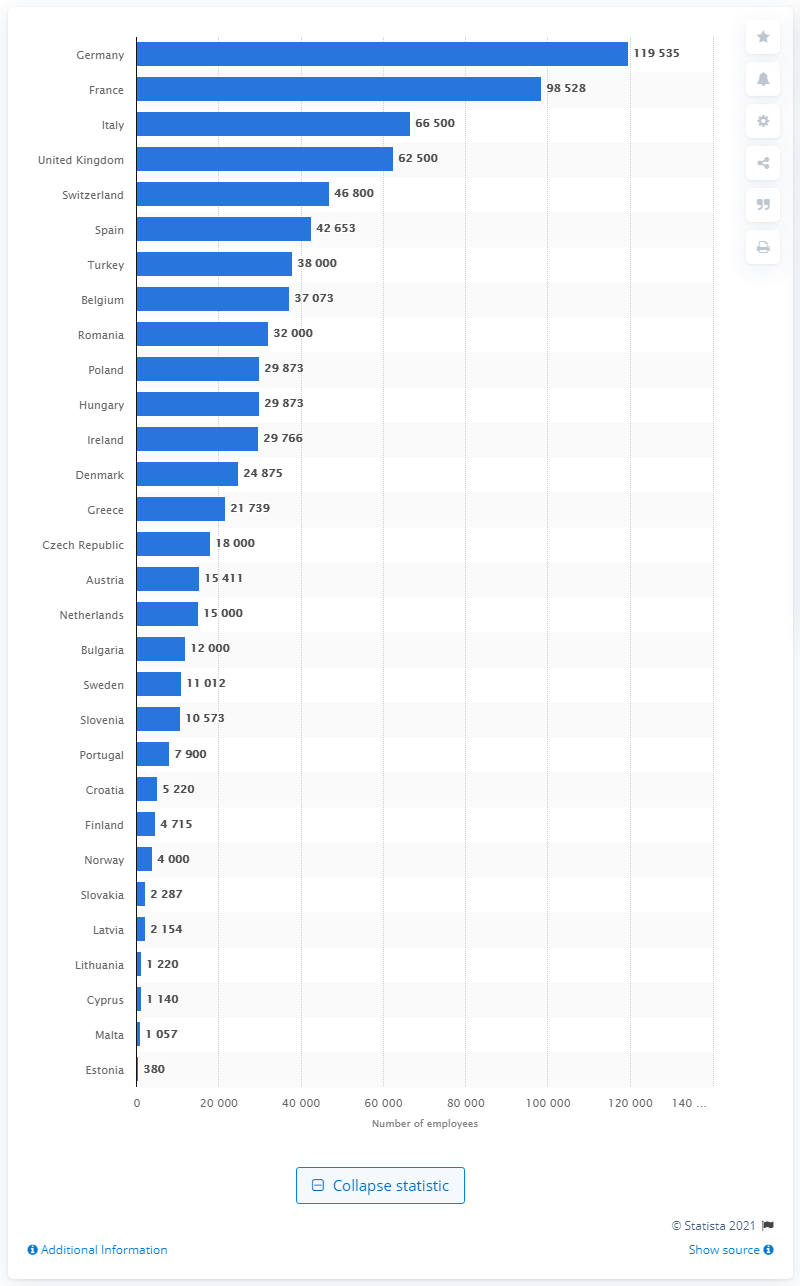Give some essential details in this illustration. In 2018, a total of 24,875 individuals were employed within the pharmaceutical industry in Denmark. 